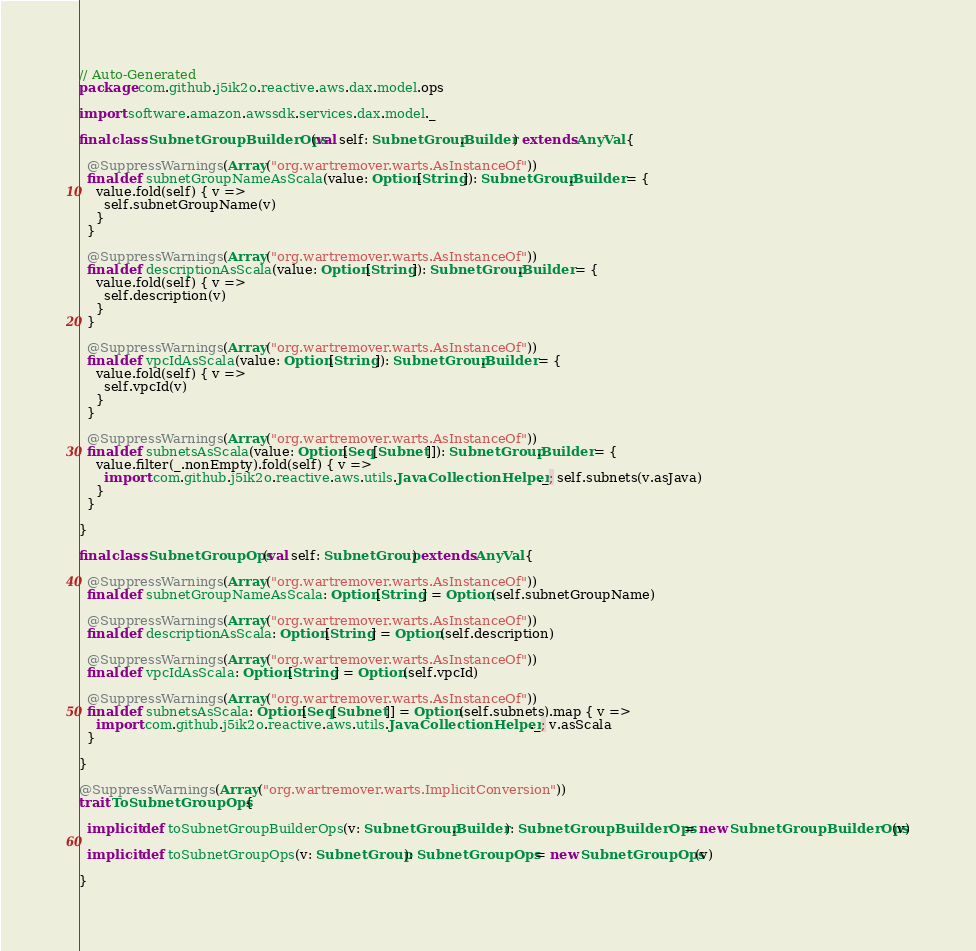Convert code to text. <code><loc_0><loc_0><loc_500><loc_500><_Scala_>// Auto-Generated
package com.github.j5ik2o.reactive.aws.dax.model.ops

import software.amazon.awssdk.services.dax.model._

final class SubnetGroupBuilderOps(val self: SubnetGroup.Builder) extends AnyVal {

  @SuppressWarnings(Array("org.wartremover.warts.AsInstanceOf"))
  final def subnetGroupNameAsScala(value: Option[String]): SubnetGroup.Builder = {
    value.fold(self) { v =>
      self.subnetGroupName(v)
    }
  }

  @SuppressWarnings(Array("org.wartremover.warts.AsInstanceOf"))
  final def descriptionAsScala(value: Option[String]): SubnetGroup.Builder = {
    value.fold(self) { v =>
      self.description(v)
    }
  }

  @SuppressWarnings(Array("org.wartremover.warts.AsInstanceOf"))
  final def vpcIdAsScala(value: Option[String]): SubnetGroup.Builder = {
    value.fold(self) { v =>
      self.vpcId(v)
    }
  }

  @SuppressWarnings(Array("org.wartremover.warts.AsInstanceOf"))
  final def subnetsAsScala(value: Option[Seq[Subnet]]): SubnetGroup.Builder = {
    value.filter(_.nonEmpty).fold(self) { v =>
      import com.github.j5ik2o.reactive.aws.utils.JavaCollectionHelper._; self.subnets(v.asJava)
    }
  }

}

final class SubnetGroupOps(val self: SubnetGroup) extends AnyVal {

  @SuppressWarnings(Array("org.wartremover.warts.AsInstanceOf"))
  final def subnetGroupNameAsScala: Option[String] = Option(self.subnetGroupName)

  @SuppressWarnings(Array("org.wartremover.warts.AsInstanceOf"))
  final def descriptionAsScala: Option[String] = Option(self.description)

  @SuppressWarnings(Array("org.wartremover.warts.AsInstanceOf"))
  final def vpcIdAsScala: Option[String] = Option(self.vpcId)

  @SuppressWarnings(Array("org.wartremover.warts.AsInstanceOf"))
  final def subnetsAsScala: Option[Seq[Subnet]] = Option(self.subnets).map { v =>
    import com.github.j5ik2o.reactive.aws.utils.JavaCollectionHelper._; v.asScala
  }

}

@SuppressWarnings(Array("org.wartremover.warts.ImplicitConversion"))
trait ToSubnetGroupOps {

  implicit def toSubnetGroupBuilderOps(v: SubnetGroup.Builder): SubnetGroupBuilderOps = new SubnetGroupBuilderOps(v)

  implicit def toSubnetGroupOps(v: SubnetGroup): SubnetGroupOps = new SubnetGroupOps(v)

}
</code> 